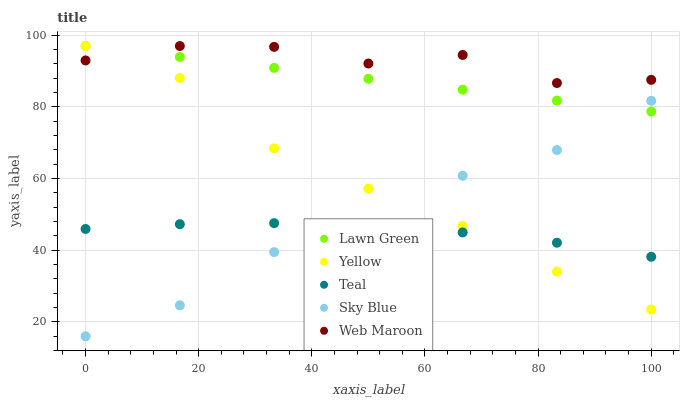Does Teal have the minimum area under the curve?
Answer yes or no. Yes. Does Web Maroon have the maximum area under the curve?
Answer yes or no. Yes. Does Web Maroon have the minimum area under the curve?
Answer yes or no. No. Does Teal have the maximum area under the curve?
Answer yes or no. No. Is Lawn Green the smoothest?
Answer yes or no. Yes. Is Sky Blue the roughest?
Answer yes or no. Yes. Is Web Maroon the smoothest?
Answer yes or no. No. Is Web Maroon the roughest?
Answer yes or no. No. Does Sky Blue have the lowest value?
Answer yes or no. Yes. Does Teal have the lowest value?
Answer yes or no. No. Does Yellow have the highest value?
Answer yes or no. Yes. Does Teal have the highest value?
Answer yes or no. No. Is Sky Blue less than Web Maroon?
Answer yes or no. Yes. Is Lawn Green greater than Teal?
Answer yes or no. Yes. Does Lawn Green intersect Sky Blue?
Answer yes or no. Yes. Is Lawn Green less than Sky Blue?
Answer yes or no. No. Is Lawn Green greater than Sky Blue?
Answer yes or no. No. Does Sky Blue intersect Web Maroon?
Answer yes or no. No. 